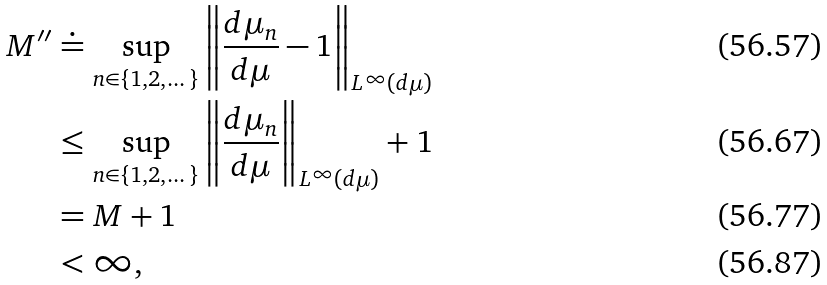Convert formula to latex. <formula><loc_0><loc_0><loc_500><loc_500>M ^ { \prime \prime } & \doteq \sup _ { n \in \{ 1 , 2 , \dots \} } \left \| \frac { d \mu _ { n } } { d \mu } - 1 \right \| _ { L ^ { \infty } ( d \mu ) } \\ & \leq \sup _ { n \in \{ 1 , 2 , \dots \} } \left \| \frac { d \mu _ { n } } { d \mu } \right \| _ { L ^ { \infty } ( d \mu ) } + 1 \\ & = M + 1 \\ & < \infty ,</formula> 